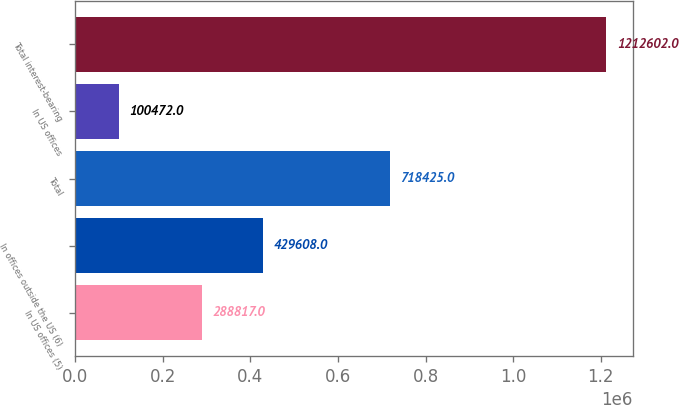Convert chart. <chart><loc_0><loc_0><loc_500><loc_500><bar_chart><fcel>In US offices (5)<fcel>In offices outside the US (6)<fcel>Total<fcel>In US offices<fcel>Total interest-bearing<nl><fcel>288817<fcel>429608<fcel>718425<fcel>100472<fcel>1.2126e+06<nl></chart> 